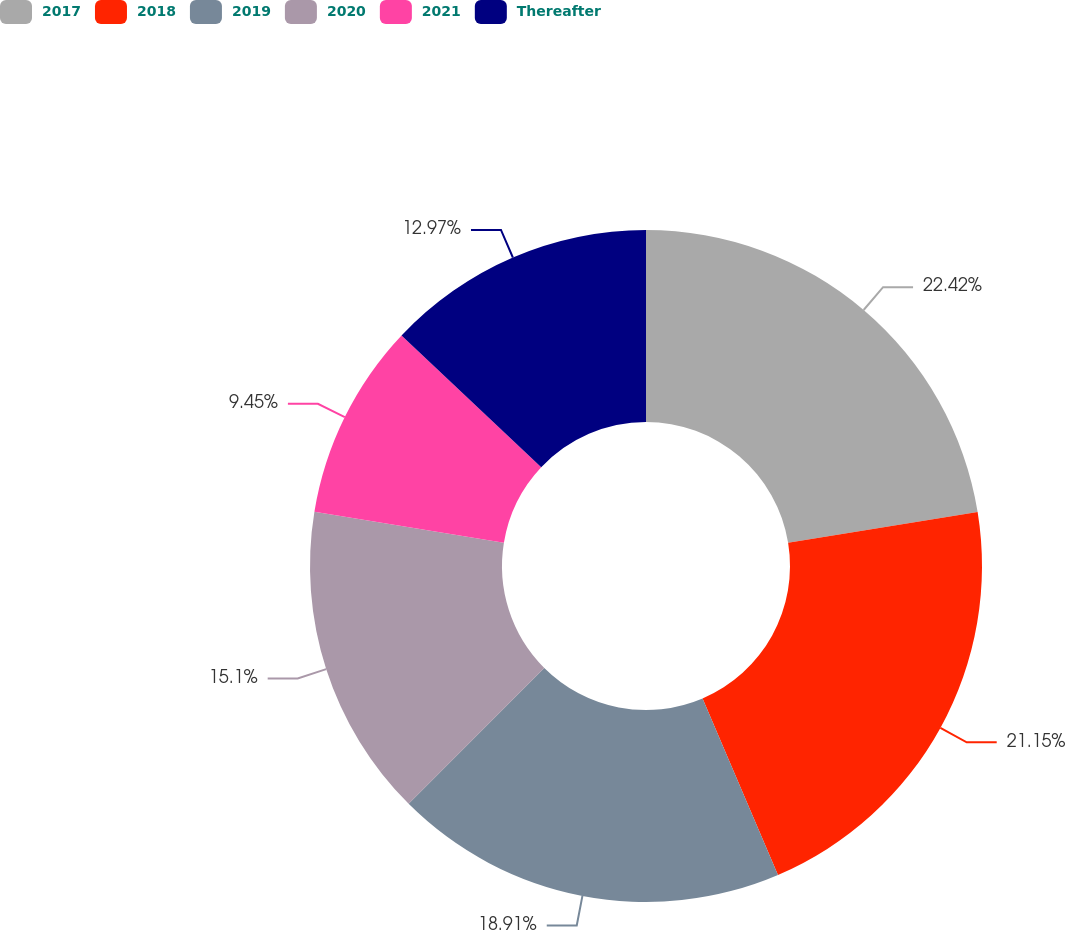<chart> <loc_0><loc_0><loc_500><loc_500><pie_chart><fcel>2017<fcel>2018<fcel>2019<fcel>2020<fcel>2021<fcel>Thereafter<nl><fcel>22.43%<fcel>21.15%<fcel>18.91%<fcel>15.1%<fcel>9.45%<fcel>12.97%<nl></chart> 